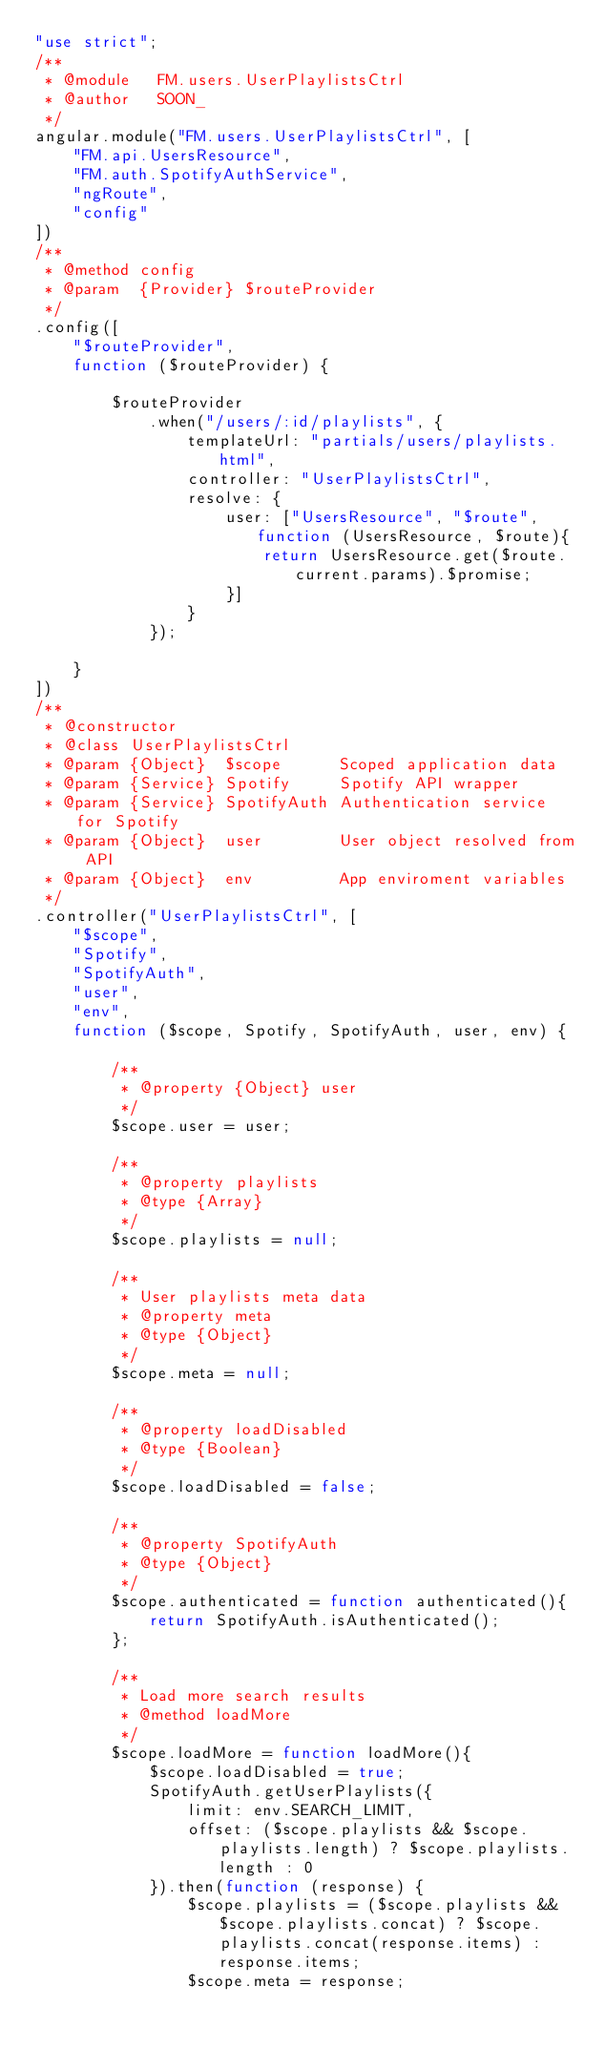<code> <loc_0><loc_0><loc_500><loc_500><_JavaScript_>"use strict";
/**
 * @module   FM.users.UserPlaylistsCtrl
 * @author   SOON_
 */
angular.module("FM.users.UserPlaylistsCtrl", [
    "FM.api.UsersResource",
    "FM.auth.SpotifyAuthService",
    "ngRoute",
    "config"
])
/**
 * @method config
 * @param  {Provider} $routeProvider
 */
.config([
    "$routeProvider",
    function ($routeProvider) {

        $routeProvider
            .when("/users/:id/playlists", {
                templateUrl: "partials/users/playlists.html",
                controller: "UserPlaylistsCtrl",
                resolve: {
                    user: ["UsersResource", "$route", function (UsersResource, $route){
                        return UsersResource.get($route.current.params).$promise;
                    }]
                }
            });

    }
])
/**
 * @constructor
 * @class UserPlaylistsCtrl
 * @param {Object}  $scope      Scoped application data
 * @param {Service} Spotify     Spotify API wrapper
 * @param {Service} SpotifyAuth Authentication service for Spotify
 * @param {Object}  user        User object resolved from API
 * @param {Object}  env         App enviroment variables
 */
.controller("UserPlaylistsCtrl", [
    "$scope",
    "Spotify",
    "SpotifyAuth",
    "user",
    "env",
    function ($scope, Spotify, SpotifyAuth, user, env) {

        /**
         * @property {Object} user
         */
        $scope.user = user;

        /**
         * @property playlists
         * @type {Array}
         */
        $scope.playlists = null;

        /**
         * User playlists meta data
         * @property meta
         * @type {Object}
         */
        $scope.meta = null;

        /**
         * @property loadDisabled
         * @type {Boolean}
         */
        $scope.loadDisabled = false;

        /**
         * @property SpotifyAuth
         * @type {Object}
         */
        $scope.authenticated = function authenticated(){
            return SpotifyAuth.isAuthenticated();
        };

        /**
         * Load more search results
         * @method loadMore
         */
        $scope.loadMore = function loadMore(){
            $scope.loadDisabled = true;
            SpotifyAuth.getUserPlaylists({
                limit: env.SEARCH_LIMIT,
                offset: ($scope.playlists && $scope.playlists.length) ? $scope.playlists.length : 0
            }).then(function (response) {
                $scope.playlists = ($scope.playlists && $scope.playlists.concat) ? $scope.playlists.concat(response.items) : response.items;
                $scope.meta = response;</code> 